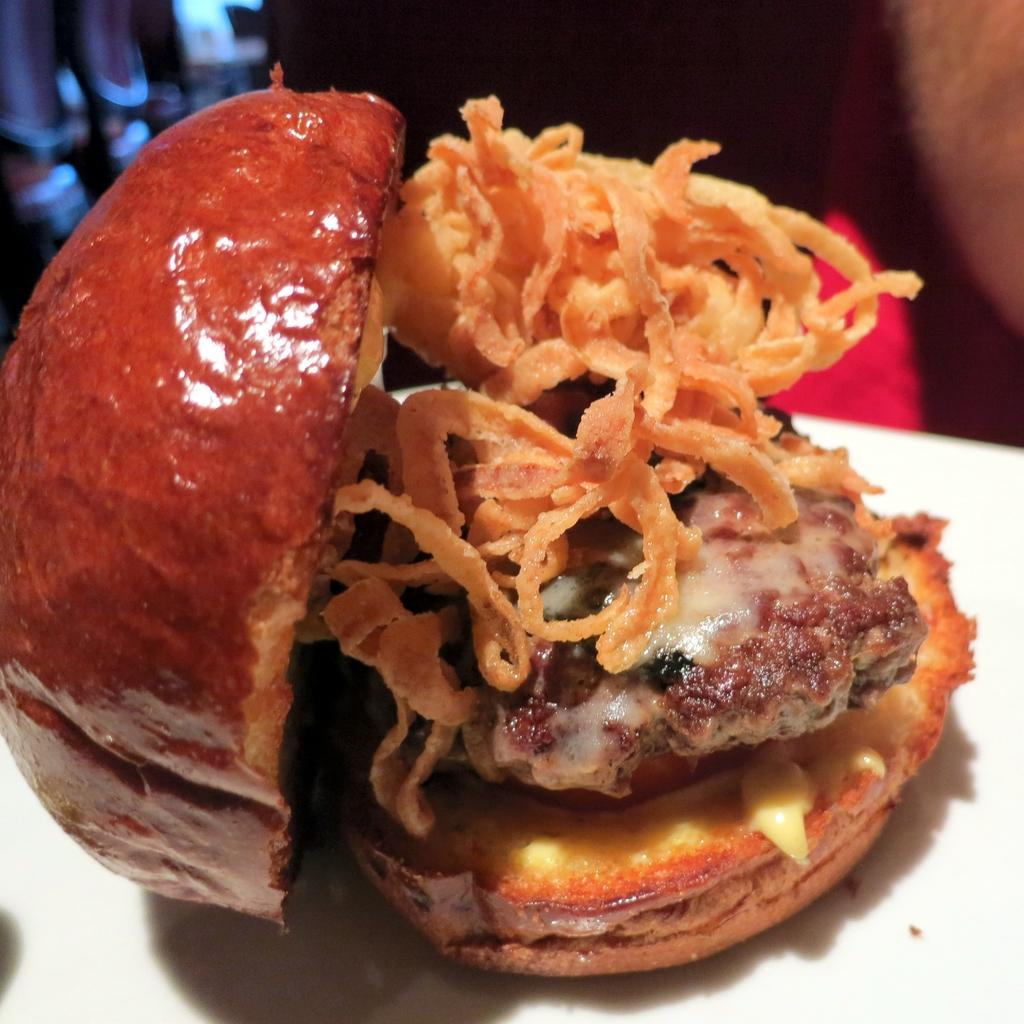What type of food is in the image? There is a burger in the image. Where is the burger located? The burger is on a table. How many tickets are visible in the image? There are no tickets present in the image. What type of corn is growing in the image? There is no corn present in the image. 